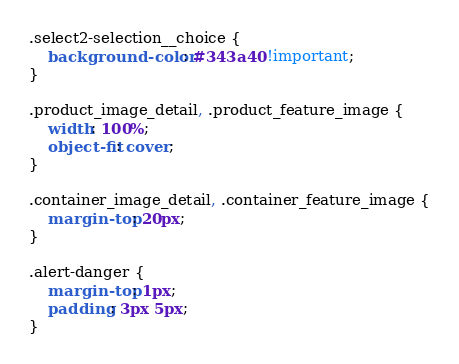<code> <loc_0><loc_0><loc_500><loc_500><_CSS_>.select2-selection__choice {
    background-color: #343a40 !important;
}

.product_image_detail, .product_feature_image {
    width: 100%;
    object-fit: cover;
}

.container_image_detail, .container_feature_image {
    margin-top: 20px;
}

.alert-danger {
    margin-top: 1px;
    padding: 3px 5px;
}

</code> 